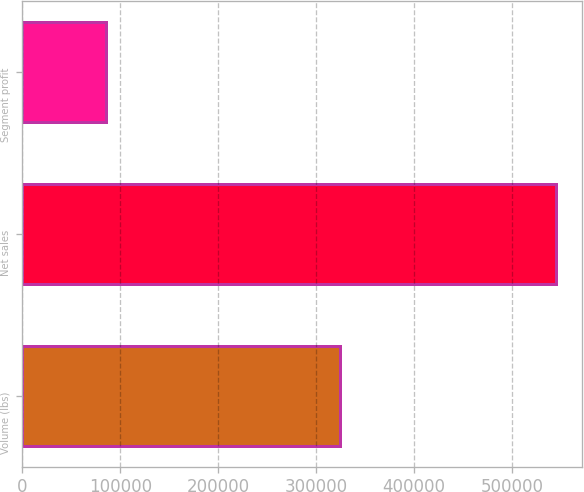Convert chart to OTSL. <chart><loc_0><loc_0><loc_500><loc_500><bar_chart><fcel>Volume (lbs)<fcel>Net sales<fcel>Segment profit<nl><fcel>324895<fcel>545014<fcel>85304<nl></chart> 